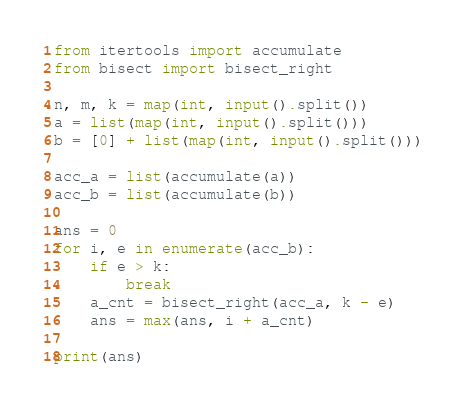<code> <loc_0><loc_0><loc_500><loc_500><_Python_>from itertools import accumulate
from bisect import bisect_right

n, m, k = map(int, input().split())
a = list(map(int, input().split()))
b = [0] + list(map(int, input().split()))

acc_a = list(accumulate(a))
acc_b = list(accumulate(b))

ans = 0
for i, e in enumerate(acc_b):
    if e > k:
        break
    a_cnt = bisect_right(acc_a, k - e)
    ans = max(ans, i + a_cnt)

print(ans)
</code> 